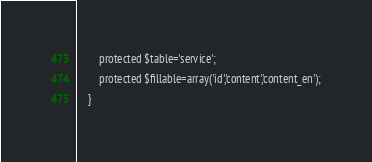<code> <loc_0><loc_0><loc_500><loc_500><_PHP_>		protected $table='service';
		protected $fillable=array('id','content','content_en');
	}</code> 